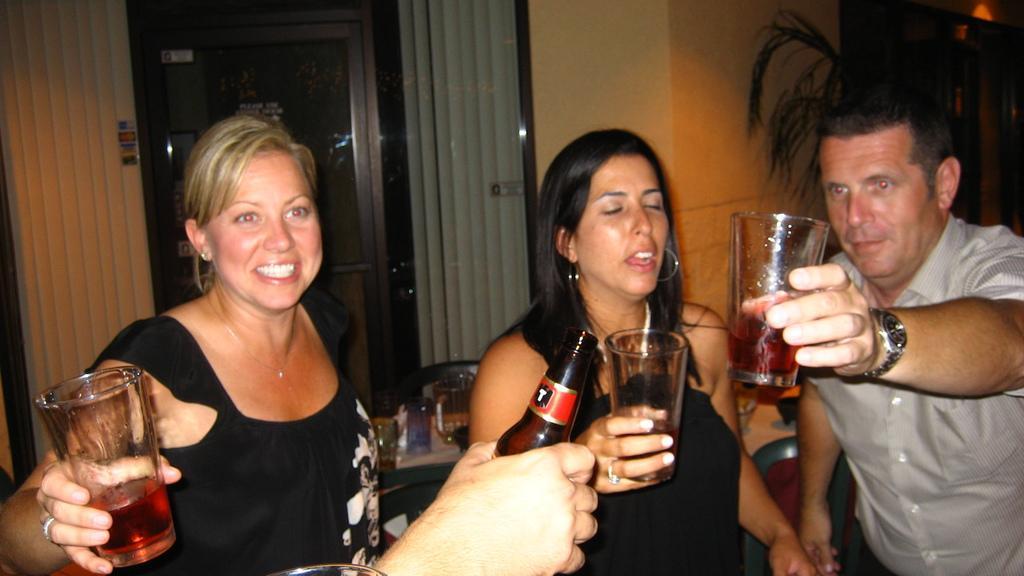Please provide a concise description of this image. There are group of people standing and holding glasses with juice and there is man holding a bottle with alcohol and behind them there is a plant and and there back there are curtains hanging on the window and a door to access. 